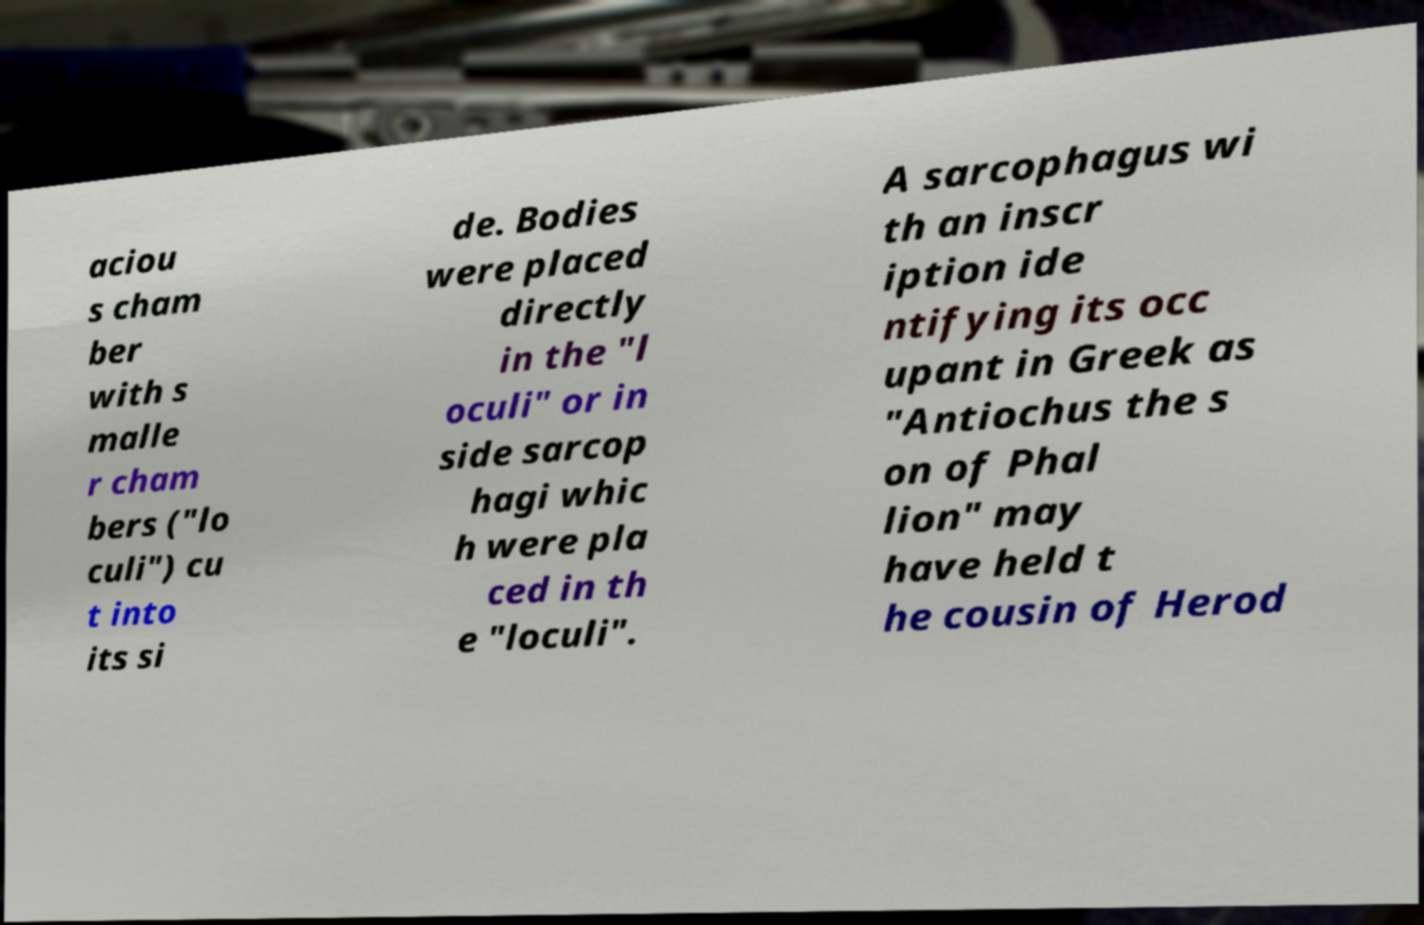Can you accurately transcribe the text from the provided image for me? aciou s cham ber with s malle r cham bers ("lo culi") cu t into its si de. Bodies were placed directly in the "l oculi" or in side sarcop hagi whic h were pla ced in th e "loculi". A sarcophagus wi th an inscr iption ide ntifying its occ upant in Greek as "Antiochus the s on of Phal lion" may have held t he cousin of Herod 